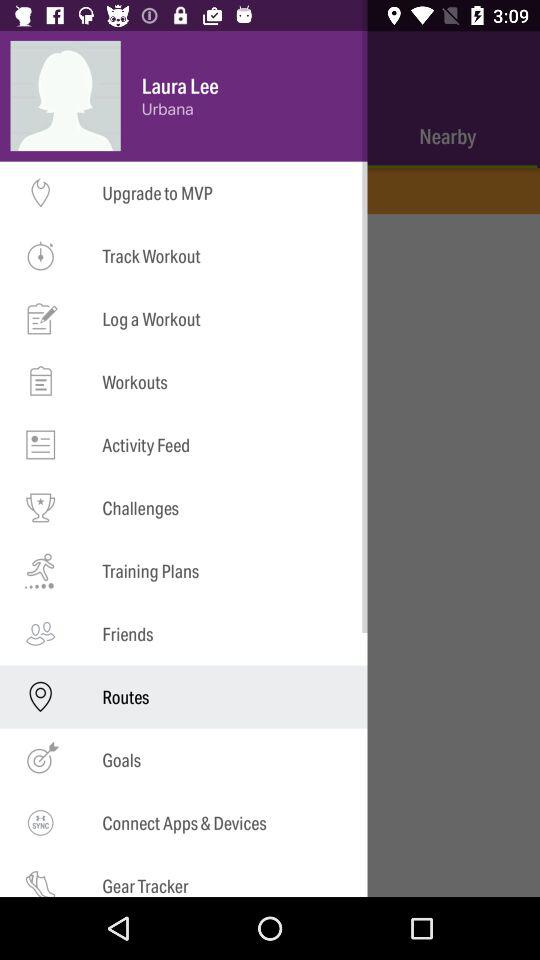Who is listed as a friend?
When the provided information is insufficient, respond with <no answer>. <no answer> 